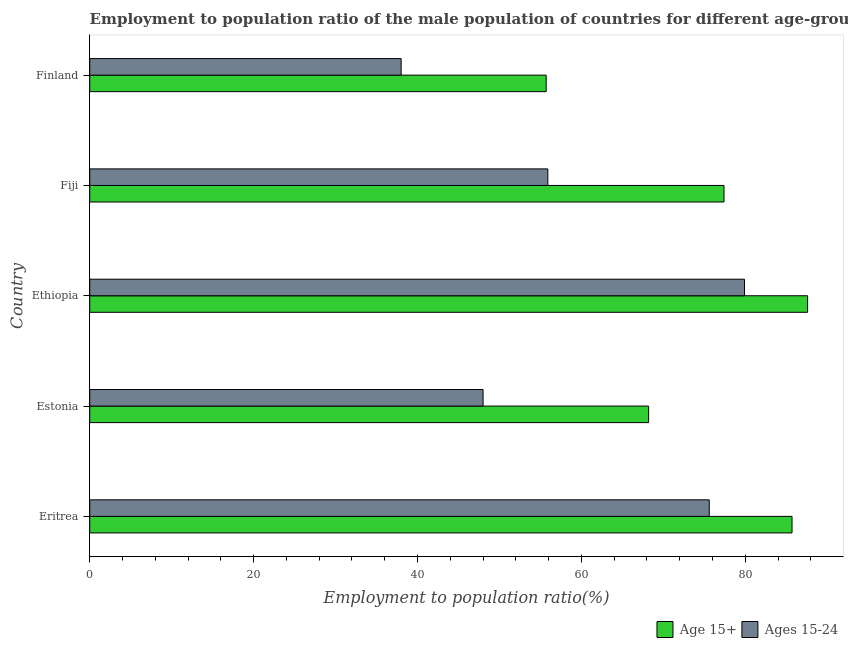How many different coloured bars are there?
Make the answer very short. 2. How many bars are there on the 4th tick from the top?
Your response must be concise. 2. What is the label of the 4th group of bars from the top?
Give a very brief answer. Estonia. In how many cases, is the number of bars for a given country not equal to the number of legend labels?
Offer a very short reply. 0. What is the employment to population ratio(age 15-24) in Ethiopia?
Provide a short and direct response. 79.9. Across all countries, what is the maximum employment to population ratio(age 15+)?
Make the answer very short. 87.6. Across all countries, what is the minimum employment to population ratio(age 15+)?
Provide a short and direct response. 55.7. In which country was the employment to population ratio(age 15+) maximum?
Provide a short and direct response. Ethiopia. What is the total employment to population ratio(age 15+) in the graph?
Offer a terse response. 374.6. What is the difference between the employment to population ratio(age 15-24) in Ethiopia and that in Fiji?
Provide a succinct answer. 24. What is the difference between the employment to population ratio(age 15+) in Estonia and the employment to population ratio(age 15-24) in Eritrea?
Your answer should be very brief. -7.4. What is the average employment to population ratio(age 15+) per country?
Provide a succinct answer. 74.92. What is the difference between the employment to population ratio(age 15-24) and employment to population ratio(age 15+) in Ethiopia?
Provide a succinct answer. -7.7. What is the ratio of the employment to population ratio(age 15+) in Fiji to that in Finland?
Provide a short and direct response. 1.39. What is the difference between the highest and the second highest employment to population ratio(age 15-24)?
Offer a terse response. 4.3. What is the difference between the highest and the lowest employment to population ratio(age 15+)?
Ensure brevity in your answer.  31.9. What does the 1st bar from the top in Ethiopia represents?
Your answer should be compact. Ages 15-24. What does the 1st bar from the bottom in Ethiopia represents?
Ensure brevity in your answer.  Age 15+. What is the difference between two consecutive major ticks on the X-axis?
Ensure brevity in your answer.  20. Are the values on the major ticks of X-axis written in scientific E-notation?
Make the answer very short. No. Does the graph contain any zero values?
Offer a terse response. No. How many legend labels are there?
Keep it short and to the point. 2. How are the legend labels stacked?
Provide a succinct answer. Horizontal. What is the title of the graph?
Keep it short and to the point. Employment to population ratio of the male population of countries for different age-groups. What is the label or title of the Y-axis?
Provide a succinct answer. Country. What is the Employment to population ratio(%) in Age 15+ in Eritrea?
Your response must be concise. 85.7. What is the Employment to population ratio(%) in Ages 15-24 in Eritrea?
Keep it short and to the point. 75.6. What is the Employment to population ratio(%) of Age 15+ in Estonia?
Keep it short and to the point. 68.2. What is the Employment to population ratio(%) of Age 15+ in Ethiopia?
Give a very brief answer. 87.6. What is the Employment to population ratio(%) in Ages 15-24 in Ethiopia?
Give a very brief answer. 79.9. What is the Employment to population ratio(%) in Age 15+ in Fiji?
Provide a short and direct response. 77.4. What is the Employment to population ratio(%) of Ages 15-24 in Fiji?
Give a very brief answer. 55.9. What is the Employment to population ratio(%) in Age 15+ in Finland?
Your response must be concise. 55.7. Across all countries, what is the maximum Employment to population ratio(%) of Age 15+?
Your answer should be compact. 87.6. Across all countries, what is the maximum Employment to population ratio(%) of Ages 15-24?
Provide a succinct answer. 79.9. Across all countries, what is the minimum Employment to population ratio(%) of Age 15+?
Your answer should be compact. 55.7. Across all countries, what is the minimum Employment to population ratio(%) in Ages 15-24?
Provide a short and direct response. 38. What is the total Employment to population ratio(%) of Age 15+ in the graph?
Offer a terse response. 374.6. What is the total Employment to population ratio(%) of Ages 15-24 in the graph?
Your answer should be very brief. 297.4. What is the difference between the Employment to population ratio(%) of Age 15+ in Eritrea and that in Estonia?
Keep it short and to the point. 17.5. What is the difference between the Employment to population ratio(%) in Ages 15-24 in Eritrea and that in Estonia?
Keep it short and to the point. 27.6. What is the difference between the Employment to population ratio(%) in Age 15+ in Eritrea and that in Ethiopia?
Offer a terse response. -1.9. What is the difference between the Employment to population ratio(%) of Ages 15-24 in Eritrea and that in Fiji?
Provide a succinct answer. 19.7. What is the difference between the Employment to population ratio(%) in Ages 15-24 in Eritrea and that in Finland?
Offer a very short reply. 37.6. What is the difference between the Employment to population ratio(%) of Age 15+ in Estonia and that in Ethiopia?
Offer a very short reply. -19.4. What is the difference between the Employment to population ratio(%) of Ages 15-24 in Estonia and that in Ethiopia?
Ensure brevity in your answer.  -31.9. What is the difference between the Employment to population ratio(%) of Ages 15-24 in Ethiopia and that in Fiji?
Keep it short and to the point. 24. What is the difference between the Employment to population ratio(%) in Age 15+ in Ethiopia and that in Finland?
Offer a very short reply. 31.9. What is the difference between the Employment to population ratio(%) of Ages 15-24 in Ethiopia and that in Finland?
Provide a short and direct response. 41.9. What is the difference between the Employment to population ratio(%) in Age 15+ in Fiji and that in Finland?
Your answer should be compact. 21.7. What is the difference between the Employment to population ratio(%) in Age 15+ in Eritrea and the Employment to population ratio(%) in Ages 15-24 in Estonia?
Provide a short and direct response. 37.7. What is the difference between the Employment to population ratio(%) of Age 15+ in Eritrea and the Employment to population ratio(%) of Ages 15-24 in Fiji?
Provide a succinct answer. 29.8. What is the difference between the Employment to population ratio(%) of Age 15+ in Eritrea and the Employment to population ratio(%) of Ages 15-24 in Finland?
Your answer should be compact. 47.7. What is the difference between the Employment to population ratio(%) of Age 15+ in Estonia and the Employment to population ratio(%) of Ages 15-24 in Ethiopia?
Your response must be concise. -11.7. What is the difference between the Employment to population ratio(%) in Age 15+ in Estonia and the Employment to population ratio(%) in Ages 15-24 in Fiji?
Offer a terse response. 12.3. What is the difference between the Employment to population ratio(%) in Age 15+ in Estonia and the Employment to population ratio(%) in Ages 15-24 in Finland?
Make the answer very short. 30.2. What is the difference between the Employment to population ratio(%) in Age 15+ in Ethiopia and the Employment to population ratio(%) in Ages 15-24 in Fiji?
Your response must be concise. 31.7. What is the difference between the Employment to population ratio(%) of Age 15+ in Ethiopia and the Employment to population ratio(%) of Ages 15-24 in Finland?
Offer a very short reply. 49.6. What is the difference between the Employment to population ratio(%) in Age 15+ in Fiji and the Employment to population ratio(%) in Ages 15-24 in Finland?
Ensure brevity in your answer.  39.4. What is the average Employment to population ratio(%) of Age 15+ per country?
Make the answer very short. 74.92. What is the average Employment to population ratio(%) of Ages 15-24 per country?
Offer a terse response. 59.48. What is the difference between the Employment to population ratio(%) in Age 15+ and Employment to population ratio(%) in Ages 15-24 in Estonia?
Provide a succinct answer. 20.2. What is the difference between the Employment to population ratio(%) in Age 15+ and Employment to population ratio(%) in Ages 15-24 in Fiji?
Provide a short and direct response. 21.5. What is the ratio of the Employment to population ratio(%) in Age 15+ in Eritrea to that in Estonia?
Your answer should be very brief. 1.26. What is the ratio of the Employment to population ratio(%) in Ages 15-24 in Eritrea to that in Estonia?
Your answer should be very brief. 1.57. What is the ratio of the Employment to population ratio(%) of Age 15+ in Eritrea to that in Ethiopia?
Provide a short and direct response. 0.98. What is the ratio of the Employment to population ratio(%) in Ages 15-24 in Eritrea to that in Ethiopia?
Make the answer very short. 0.95. What is the ratio of the Employment to population ratio(%) of Age 15+ in Eritrea to that in Fiji?
Provide a succinct answer. 1.11. What is the ratio of the Employment to population ratio(%) of Ages 15-24 in Eritrea to that in Fiji?
Provide a succinct answer. 1.35. What is the ratio of the Employment to population ratio(%) in Age 15+ in Eritrea to that in Finland?
Provide a short and direct response. 1.54. What is the ratio of the Employment to population ratio(%) of Ages 15-24 in Eritrea to that in Finland?
Your answer should be compact. 1.99. What is the ratio of the Employment to population ratio(%) of Age 15+ in Estonia to that in Ethiopia?
Provide a succinct answer. 0.78. What is the ratio of the Employment to population ratio(%) in Ages 15-24 in Estonia to that in Ethiopia?
Keep it short and to the point. 0.6. What is the ratio of the Employment to population ratio(%) in Age 15+ in Estonia to that in Fiji?
Offer a terse response. 0.88. What is the ratio of the Employment to population ratio(%) in Ages 15-24 in Estonia to that in Fiji?
Offer a terse response. 0.86. What is the ratio of the Employment to population ratio(%) in Age 15+ in Estonia to that in Finland?
Keep it short and to the point. 1.22. What is the ratio of the Employment to population ratio(%) in Ages 15-24 in Estonia to that in Finland?
Offer a terse response. 1.26. What is the ratio of the Employment to population ratio(%) of Age 15+ in Ethiopia to that in Fiji?
Provide a short and direct response. 1.13. What is the ratio of the Employment to population ratio(%) in Ages 15-24 in Ethiopia to that in Fiji?
Offer a terse response. 1.43. What is the ratio of the Employment to population ratio(%) in Age 15+ in Ethiopia to that in Finland?
Ensure brevity in your answer.  1.57. What is the ratio of the Employment to population ratio(%) in Ages 15-24 in Ethiopia to that in Finland?
Make the answer very short. 2.1. What is the ratio of the Employment to population ratio(%) in Age 15+ in Fiji to that in Finland?
Your answer should be compact. 1.39. What is the ratio of the Employment to population ratio(%) of Ages 15-24 in Fiji to that in Finland?
Keep it short and to the point. 1.47. What is the difference between the highest and the lowest Employment to population ratio(%) in Age 15+?
Provide a succinct answer. 31.9. What is the difference between the highest and the lowest Employment to population ratio(%) of Ages 15-24?
Provide a succinct answer. 41.9. 